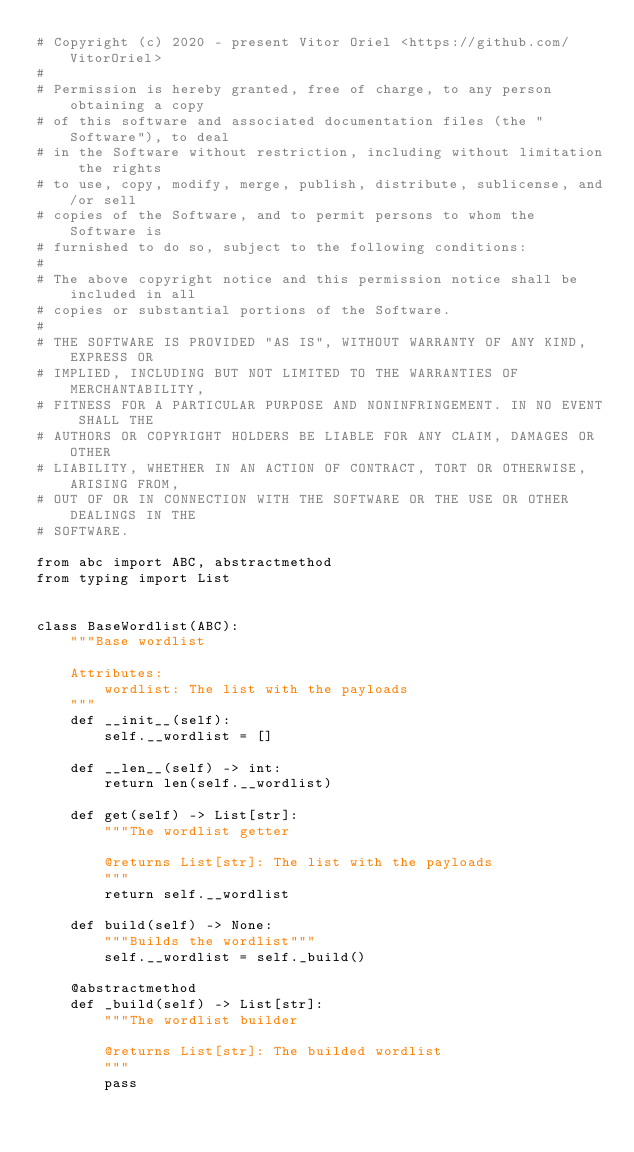<code> <loc_0><loc_0><loc_500><loc_500><_Python_># Copyright (c) 2020 - present Vitor Oriel <https://github.com/VitorOriel>
#
# Permission is hereby granted, free of charge, to any person obtaining a copy
# of this software and associated documentation files (the "Software"), to deal
# in the Software without restriction, including without limitation the rights
# to use, copy, modify, merge, publish, distribute, sublicense, and/or sell
# copies of the Software, and to permit persons to whom the Software is
# furnished to do so, subject to the following conditions:
#
# The above copyright notice and this permission notice shall be included in all
# copies or substantial portions of the Software.
#
# THE SOFTWARE IS PROVIDED "AS IS", WITHOUT WARRANTY OF ANY KIND, EXPRESS OR
# IMPLIED, INCLUDING BUT NOT LIMITED TO THE WARRANTIES OF MERCHANTABILITY,
# FITNESS FOR A PARTICULAR PURPOSE AND NONINFRINGEMENT. IN NO EVENT SHALL THE
# AUTHORS OR COPYRIGHT HOLDERS BE LIABLE FOR ANY CLAIM, DAMAGES OR OTHER
# LIABILITY, WHETHER IN AN ACTION OF CONTRACT, TORT OR OTHERWISE, ARISING FROM,
# OUT OF OR IN CONNECTION WITH THE SOFTWARE OR THE USE OR OTHER DEALINGS IN THE
# SOFTWARE.

from abc import ABC, abstractmethod
from typing import List


class BaseWordlist(ABC):
    """Base wordlist

    Attributes:
        wordlist: The list with the payloads
    """
    def __init__(self):
        self.__wordlist = []

    def __len__(self) -> int:
        return len(self.__wordlist)

    def get(self) -> List[str]:
        """The wordlist getter

        @returns List[str]: The list with the payloads
        """
        return self.__wordlist

    def build(self) -> None:
        """Builds the wordlist"""
        self.__wordlist = self._build()

    @abstractmethod
    def _build(self) -> List[str]:
        """The wordlist builder

        @returns List[str]: The builded wordlist
        """
        pass
</code> 